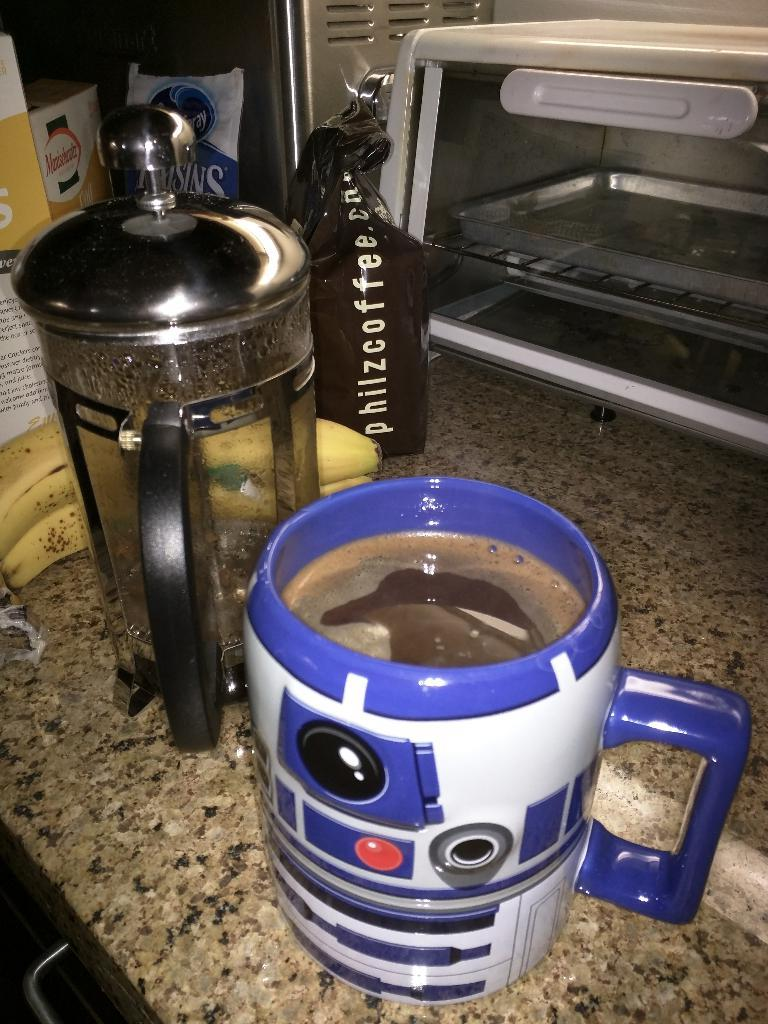<image>
Provide a brief description of the given image. A French press and a mug of coffee sit by a bag that reads Philzcoffee. 